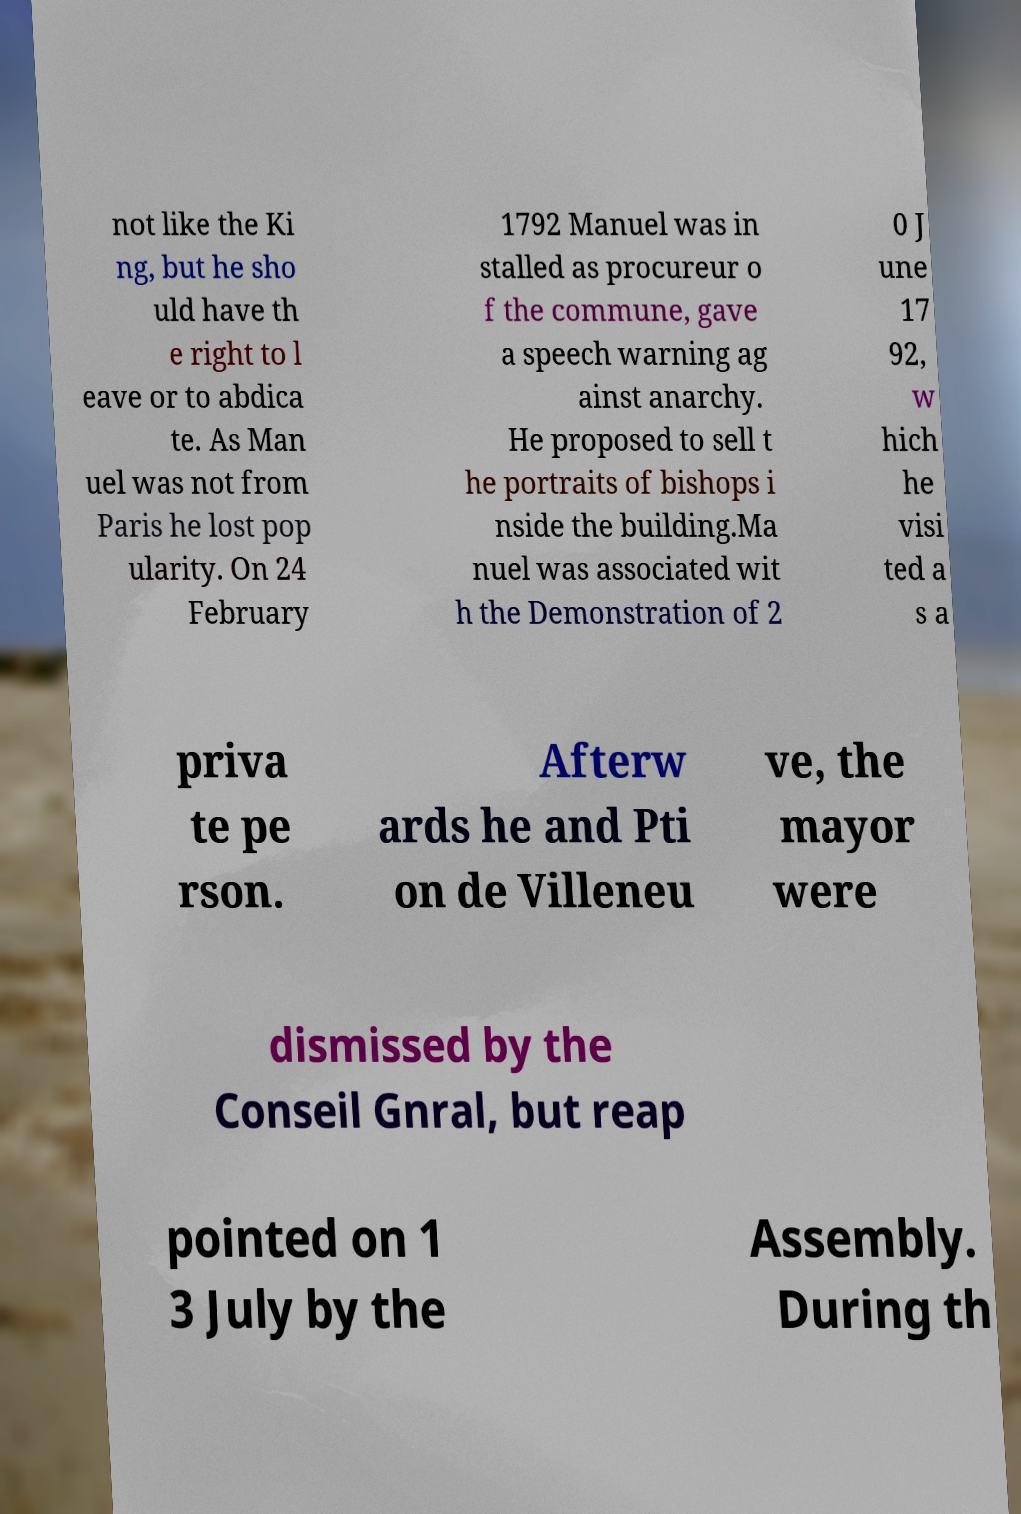Could you extract and type out the text from this image? not like the Ki ng, but he sho uld have th e right to l eave or to abdica te. As Man uel was not from Paris he lost pop ularity. On 24 February 1792 Manuel was in stalled as procureur o f the commune, gave a speech warning ag ainst anarchy. He proposed to sell t he portraits of bishops i nside the building.Ma nuel was associated wit h the Demonstration of 2 0 J une 17 92, w hich he visi ted a s a priva te pe rson. Afterw ards he and Pti on de Villeneu ve, the mayor were dismissed by the Conseil Gnral, but reap pointed on 1 3 July by the Assembly. During th 